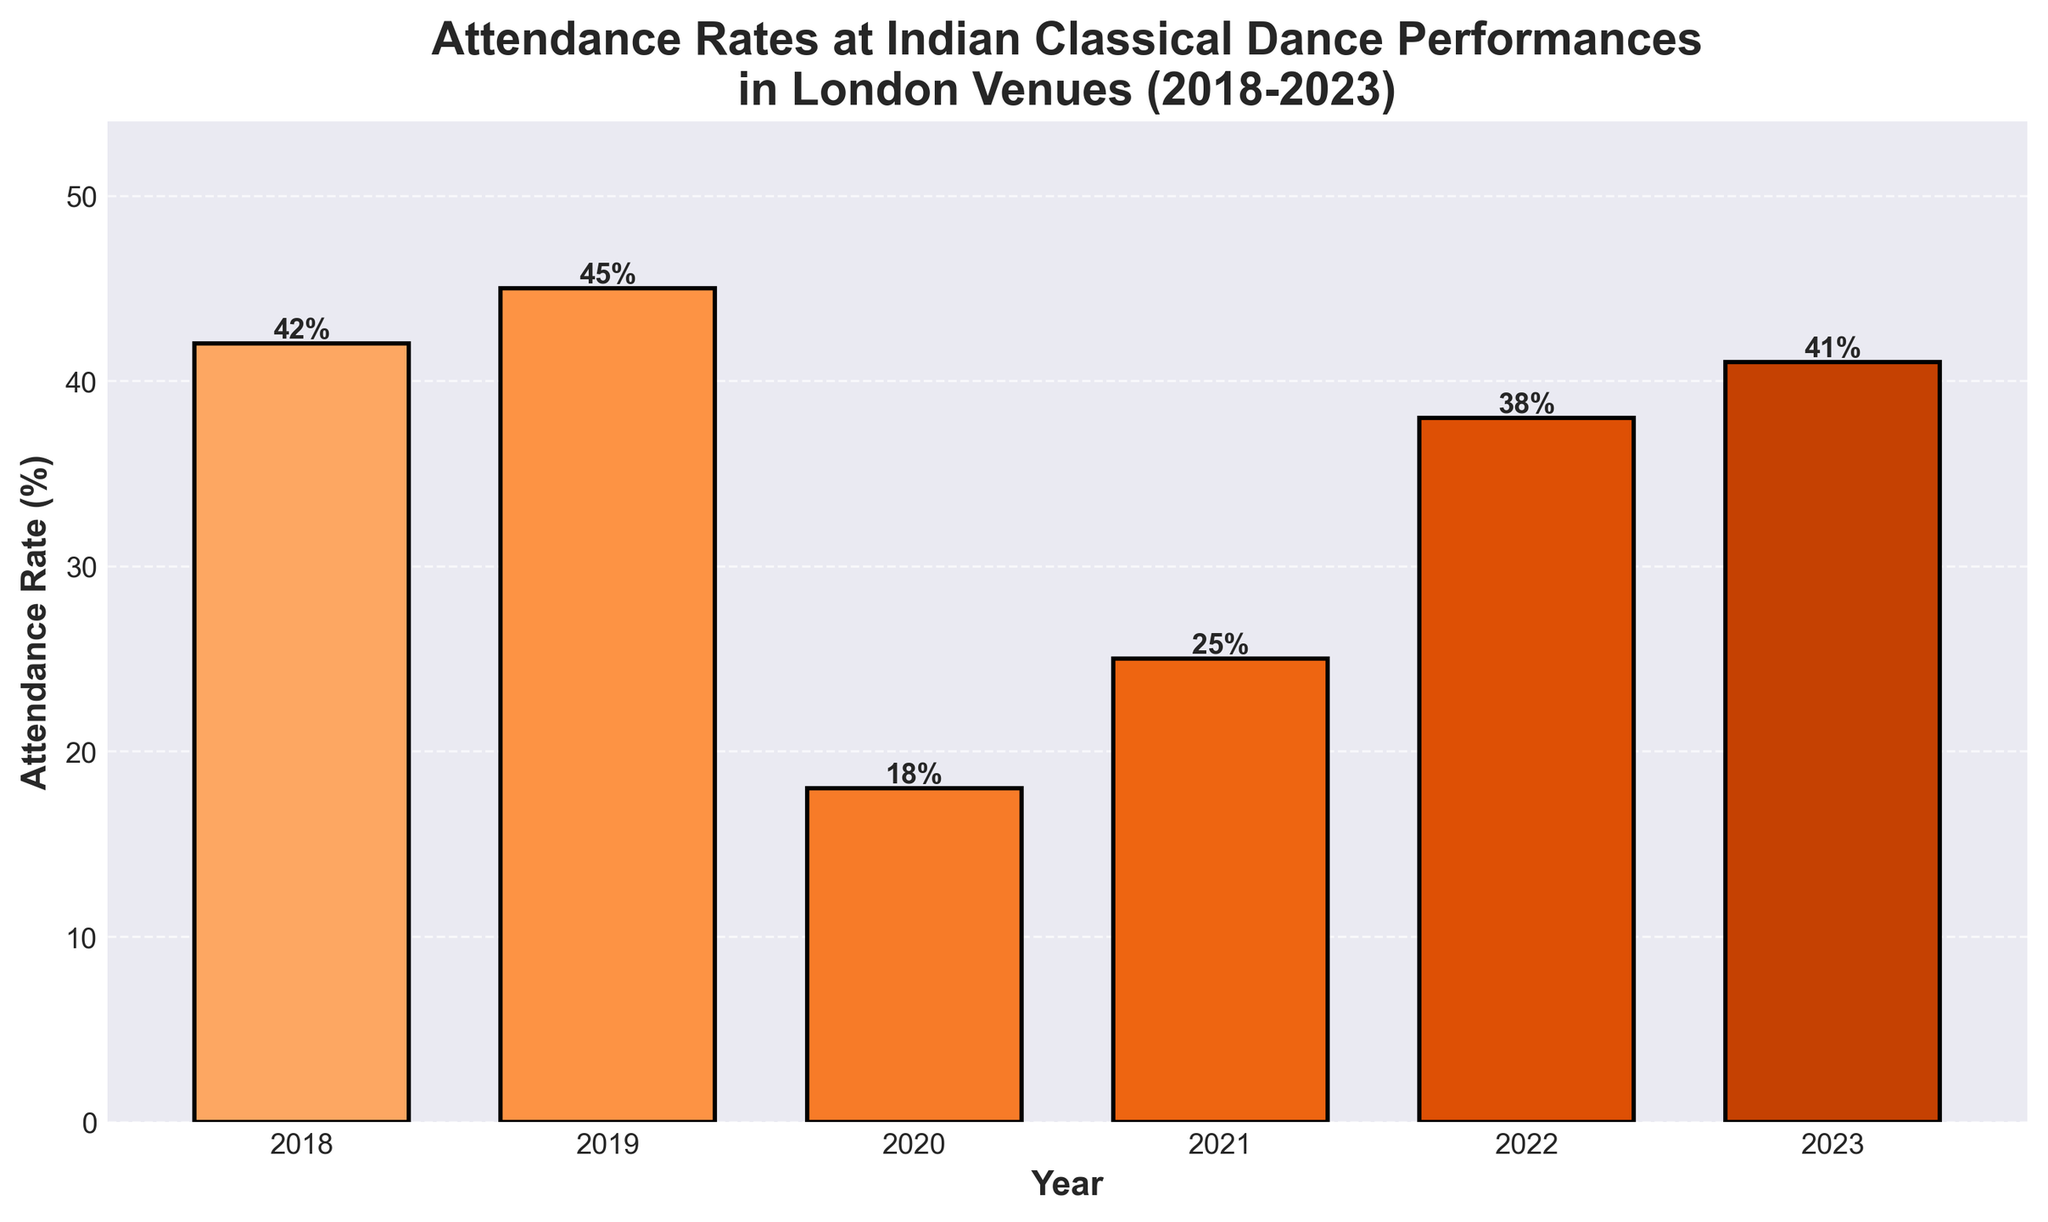What year had the lowest attendance rate? The year with the lowest bar height represents the year with the lowest attendance rate. In the chart, 2020 has the shortest bar.
Answer: 2020 Which year had the highest attendance rate? The year with the tallest bar represents the highest attendance rate. In the chart, 2019 has the tallest bar, indicating the highest attendance rate.
Answer: 2019 How did the attendance rate change from 2020 to 2021? The height of the bars for 2020 and 2021 needs to be compared. The attendance rate increased from 18% in 2020 to 25% in 2021.
Answer: Increased What is the average attendance rate across all years? Sum the attendance rates of all years (42 + 45 + 18 + 25 + 38 + 41) and divide by the number of years (6). The calculation is (209 / 6) = 34.83%.
Answer: 34.83% How many years had an attendance rate of at least 40%? Count the bars that reach or exceed the 40% mark. The bars for 2018, 2019, 2022, and 2023 reach at least 40%.
Answer: 4 years Is the attendance rate in 2022 closer to the attendance rate in 2018 or 2023? Compare the differences: the rate in 2018 is 42%, 2022 is 38%, and 2023 is 41%. The difference between 2018 and 2022 is 4%, and between 2022 and 2023 is 3%.
Answer: 2023 What was the total decrease in attendance rate from 2019 to 2020? Find the difference between the attendance rates in 2019 and 2020. The calculation is 45% - 18% = 27%.
Answer: 27% Which year's attendance rate saw the largest increase from the previous year? Calculate the difference between consecutive years and identify the largest. The differences are: (2019-2018) 3%, (2020-2019) -27%, (2021-2020) 7%, (2022-2021) 13%, (2023-2022) 3%. The largest increase is from 2021 to 2022.
Answer: 2022 What was the attendance rate in 2021 compared to 2023? Compare the heights of the bars for 2021 (25%) and 2023 (41%). The attendance rate in 2021 is lower than in 2023.
Answer: Lower What was the median attendance rate over these years? Arrange the attendance rates in ascending order [18, 25, 38, 41, 42, 45]. The median is the average of the 3rd and 4th values: (38 + 41) / 2 = 39.5%.
Answer: 39.5% 